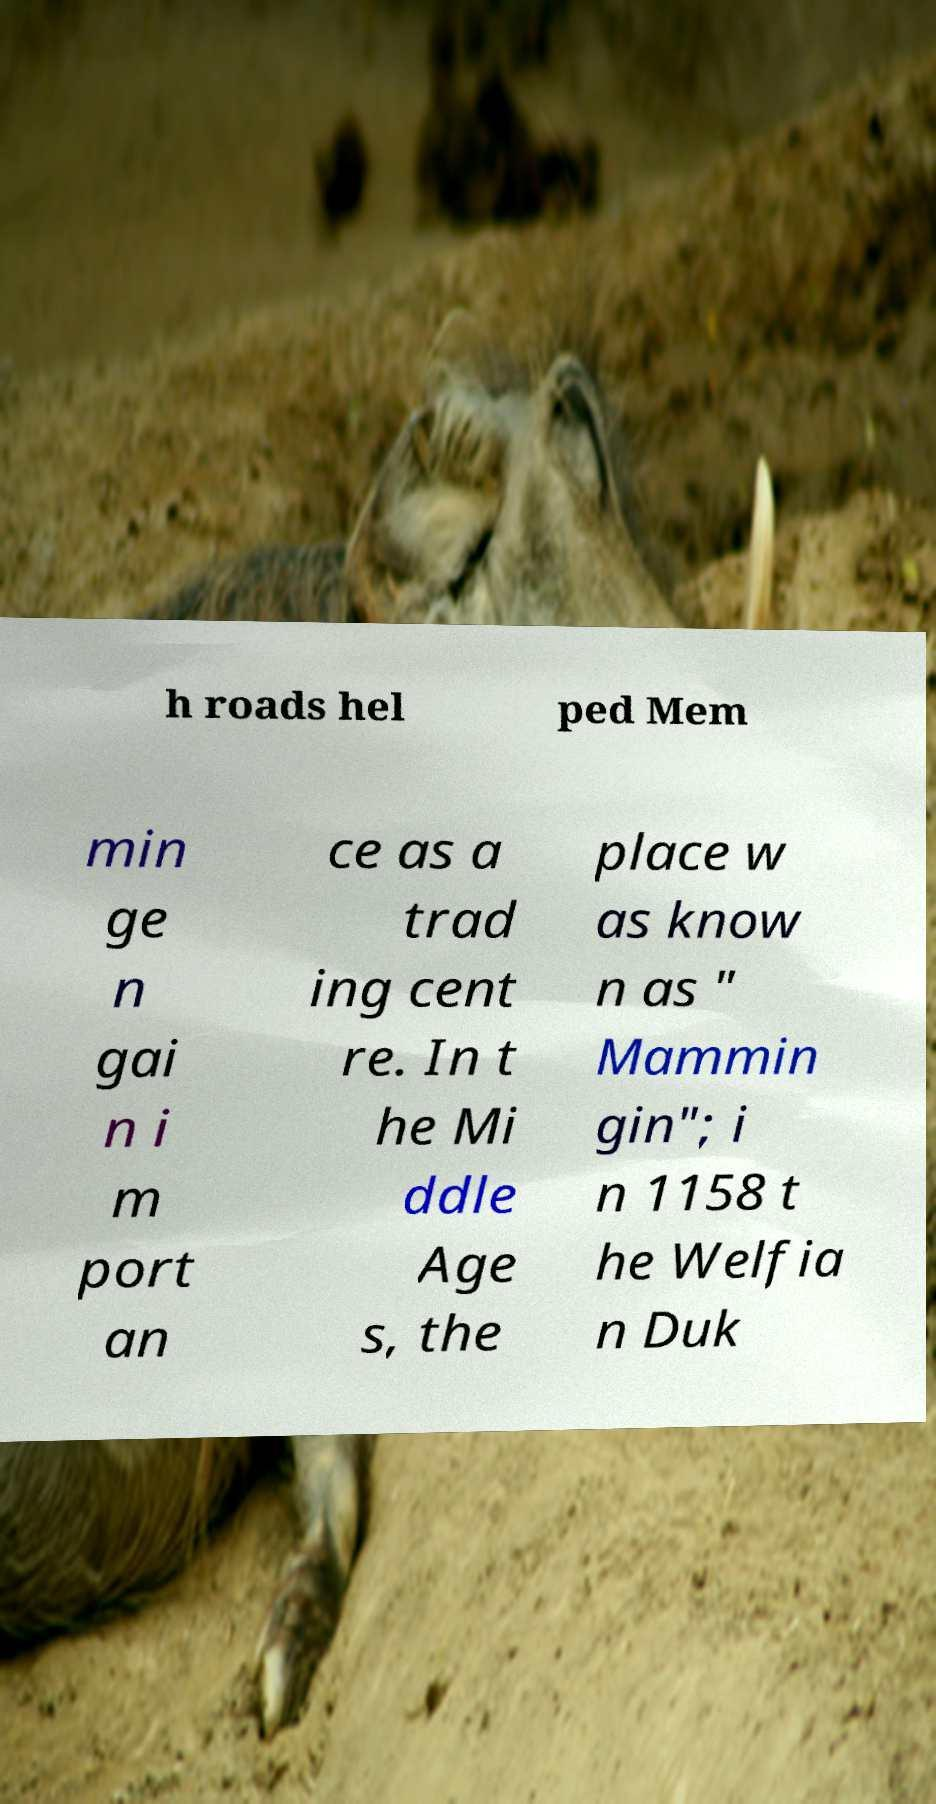There's text embedded in this image that I need extracted. Can you transcribe it verbatim? h roads hel ped Mem min ge n gai n i m port an ce as a trad ing cent re. In t he Mi ddle Age s, the place w as know n as " Mammin gin"; i n 1158 t he Welfia n Duk 